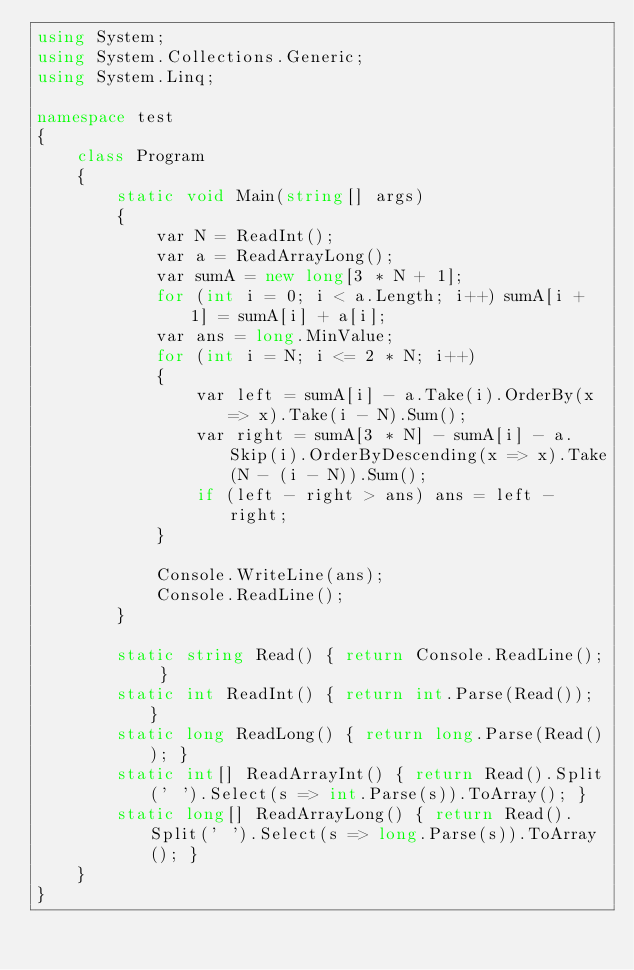<code> <loc_0><loc_0><loc_500><loc_500><_C#_>using System;
using System.Collections.Generic;
using System.Linq;

namespace test
{
    class Program
    {
        static void Main(string[] args)
        {
            var N = ReadInt();
            var a = ReadArrayLong();
            var sumA = new long[3 * N + 1];
            for (int i = 0; i < a.Length; i++) sumA[i + 1] = sumA[i] + a[i];
            var ans = long.MinValue;
            for (int i = N; i <= 2 * N; i++)
            {
                var left = sumA[i] - a.Take(i).OrderBy(x => x).Take(i - N).Sum();
                var right = sumA[3 * N] - sumA[i] - a.Skip(i).OrderByDescending(x => x).Take(N - (i - N)).Sum();
                if (left - right > ans) ans = left - right;
            }

            Console.WriteLine(ans);
            Console.ReadLine();
        }

        static string Read() { return Console.ReadLine(); }
        static int ReadInt() { return int.Parse(Read()); }
        static long ReadLong() { return long.Parse(Read()); }
        static int[] ReadArrayInt() { return Read().Split(' ').Select(s => int.Parse(s)).ToArray(); }
        static long[] ReadArrayLong() { return Read().Split(' ').Select(s => long.Parse(s)).ToArray(); }
    }
}</code> 